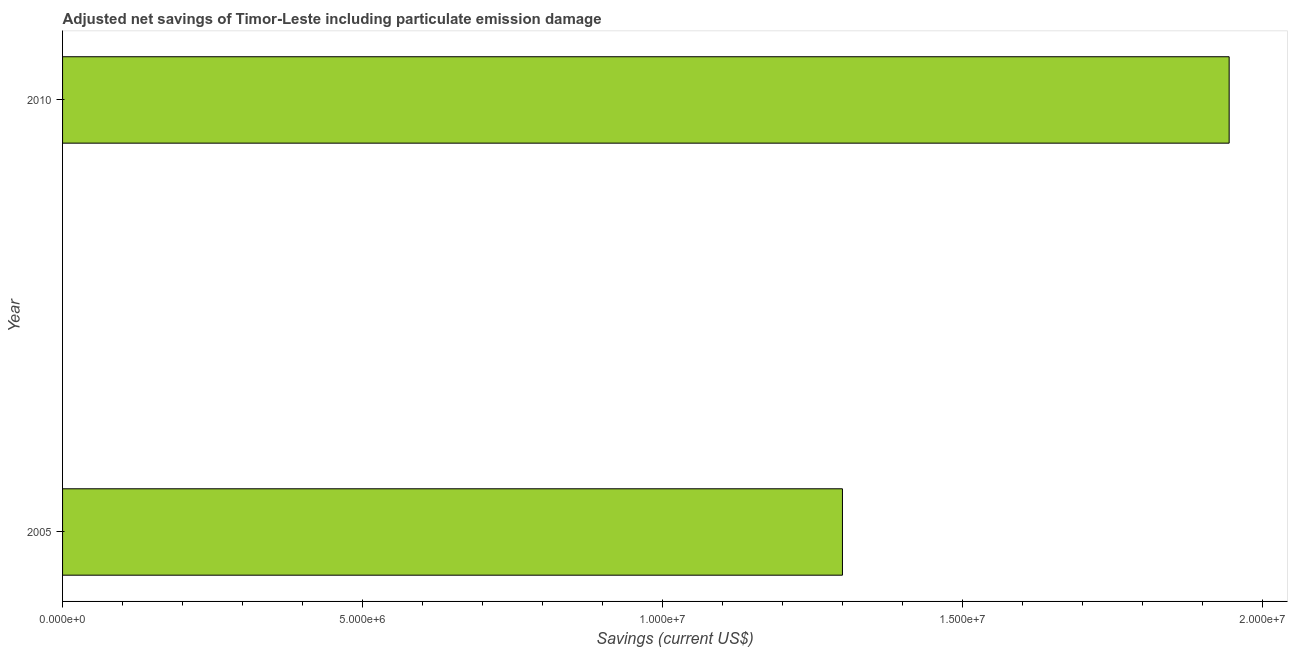Does the graph contain grids?
Provide a short and direct response. No. What is the title of the graph?
Keep it short and to the point. Adjusted net savings of Timor-Leste including particulate emission damage. What is the label or title of the X-axis?
Offer a very short reply. Savings (current US$). What is the label or title of the Y-axis?
Offer a terse response. Year. What is the adjusted net savings in 2005?
Keep it short and to the point. 1.30e+07. Across all years, what is the maximum adjusted net savings?
Provide a short and direct response. 1.94e+07. Across all years, what is the minimum adjusted net savings?
Provide a succinct answer. 1.30e+07. What is the sum of the adjusted net savings?
Provide a short and direct response. 3.24e+07. What is the difference between the adjusted net savings in 2005 and 2010?
Offer a terse response. -6.45e+06. What is the average adjusted net savings per year?
Your response must be concise. 1.62e+07. What is the median adjusted net savings?
Ensure brevity in your answer.  1.62e+07. What is the ratio of the adjusted net savings in 2005 to that in 2010?
Keep it short and to the point. 0.67. Is the adjusted net savings in 2005 less than that in 2010?
Provide a short and direct response. Yes. How many bars are there?
Give a very brief answer. 2. Are all the bars in the graph horizontal?
Offer a very short reply. Yes. What is the difference between two consecutive major ticks on the X-axis?
Your answer should be compact. 5.00e+06. Are the values on the major ticks of X-axis written in scientific E-notation?
Make the answer very short. Yes. What is the Savings (current US$) of 2005?
Ensure brevity in your answer.  1.30e+07. What is the Savings (current US$) of 2010?
Make the answer very short. 1.94e+07. What is the difference between the Savings (current US$) in 2005 and 2010?
Your answer should be compact. -6.45e+06. What is the ratio of the Savings (current US$) in 2005 to that in 2010?
Provide a succinct answer. 0.67. 